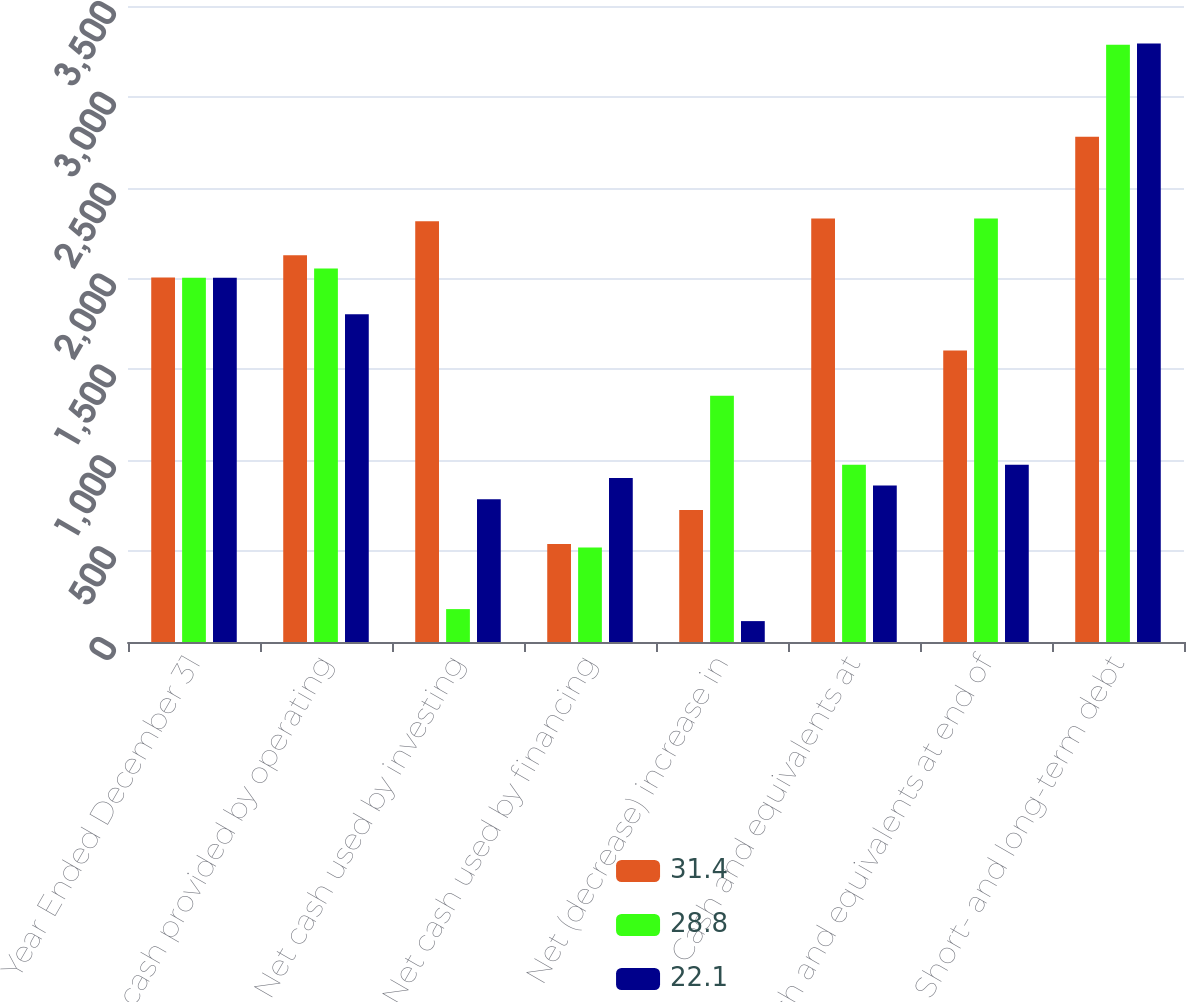Convert chart to OTSL. <chart><loc_0><loc_0><loc_500><loc_500><stacked_bar_chart><ecel><fcel>Year Ended December 31<fcel>Net cash provided by operating<fcel>Net cash used by investing<fcel>Net cash used by financing<fcel>Net (decrease) increase in<fcel>Cash and equivalents at<fcel>Cash and equivalents at end of<fcel>Short- and long-term debt<nl><fcel>31.4<fcel>2006<fcel>2128<fcel>2316<fcel>539<fcel>727<fcel>2331<fcel>1604<fcel>2781<nl><fcel>28.8<fcel>2005<fcel>2056<fcel>181<fcel>520<fcel>1355<fcel>976<fcel>2331<fcel>3287<nl><fcel>22.1<fcel>2004<fcel>1803<fcel>786<fcel>902<fcel>115<fcel>861<fcel>976<fcel>3293<nl></chart> 